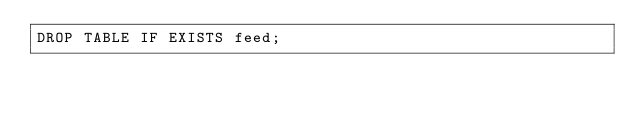<code> <loc_0><loc_0><loc_500><loc_500><_SQL_>DROP TABLE IF EXISTS feed;
</code> 